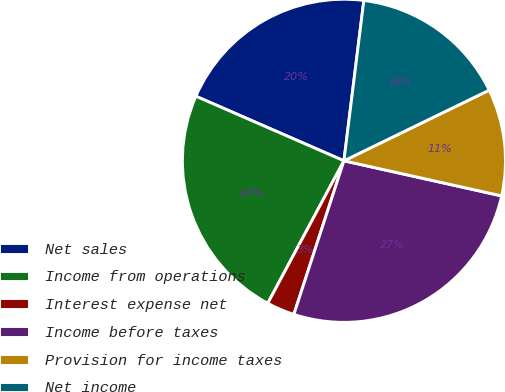Convert chart. <chart><loc_0><loc_0><loc_500><loc_500><pie_chart><fcel>Net sales<fcel>Income from operations<fcel>Interest expense net<fcel>Income before taxes<fcel>Provision for income taxes<fcel>Net income<nl><fcel>20.42%<fcel>23.73%<fcel>2.8%<fcel>26.53%<fcel>10.69%<fcel>15.83%<nl></chart> 